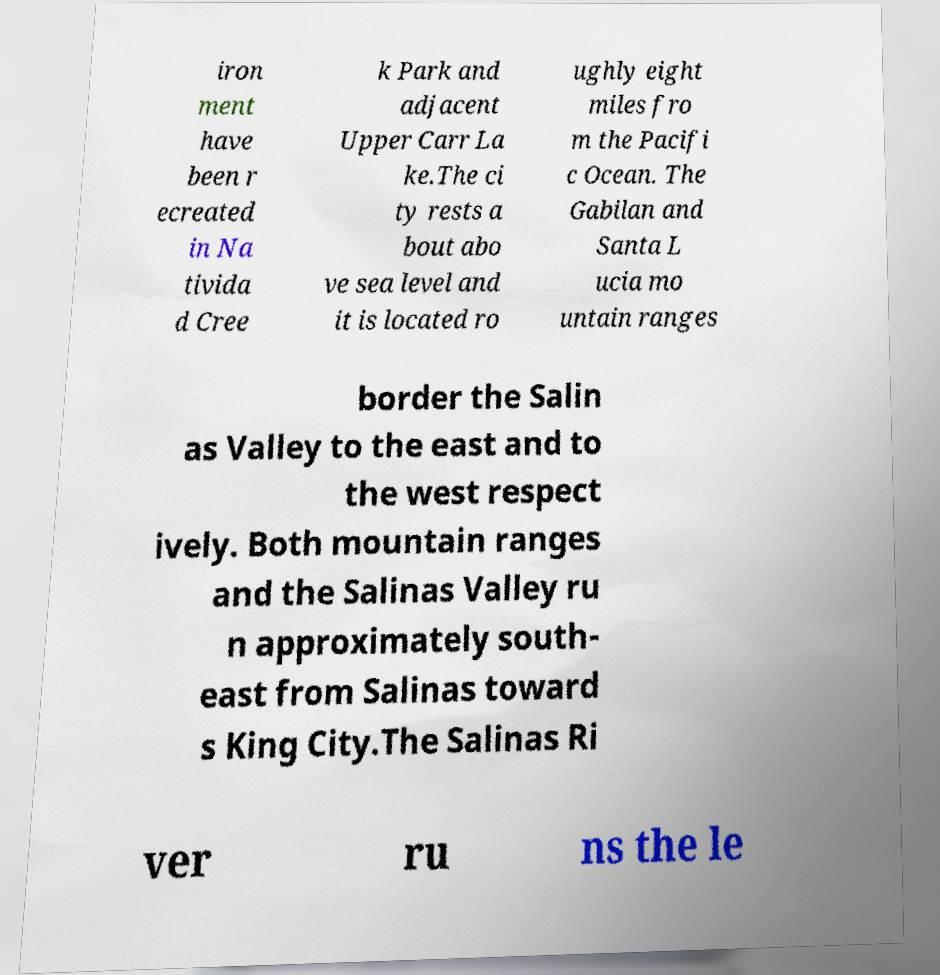What messages or text are displayed in this image? I need them in a readable, typed format. iron ment have been r ecreated in Na tivida d Cree k Park and adjacent Upper Carr La ke.The ci ty rests a bout abo ve sea level and it is located ro ughly eight miles fro m the Pacifi c Ocean. The Gabilan and Santa L ucia mo untain ranges border the Salin as Valley to the east and to the west respect ively. Both mountain ranges and the Salinas Valley ru n approximately south- east from Salinas toward s King City.The Salinas Ri ver ru ns the le 